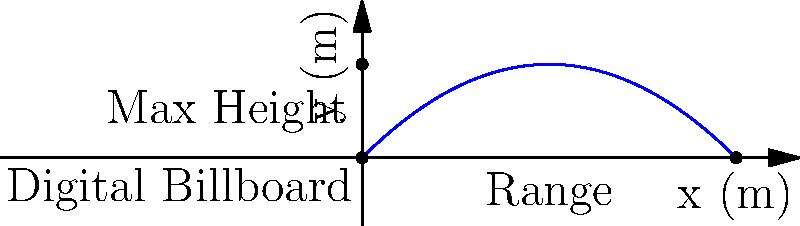A digital marketing campaign involves launching a small promotional device from the top of a digital billboard. The device is launched with an initial velocity of 20 m/s at an angle of 45° above the horizontal. Assuming air resistance is negligible, what is the maximum height reached by the device? How does this relate to the visibility of the campaign? To solve this problem, we'll follow these steps:

1) The maximum height is reached when the vertical velocity becomes zero. We can use the equation:

   $v_y = v_0 \sin \theta - gt$

   where $v_y$ is the vertical velocity, $v_0$ is the initial velocity, $\theta$ is the launch angle, $g$ is the acceleration due to gravity, and $t$ is time.

2) At the highest point, $v_y = 0$. So:

   $0 = v_0 \sin \theta - gt_{max}$

3) Solve for $t_{max}$:

   $t_{max} = \frac{v_0 \sin \theta}{g}$

4) Substitute the given values:

   $t_{max} = \frac{20 \sin 45°}{9.8} \approx 1.44$ seconds

5) Now, use the equation for the height:

   $y = v_0 \sin \theta \cdot t - \frac{1}{2}gt^2$

6) The maximum height occurs at $t = t_{max}/2$, so:

   $h_{max} = v_0 \sin \theta \cdot (\frac{t_{max}}{2}) - \frac{1}{2}g(\frac{t_{max}}{2})^2$

7) Simplify:

   $h_{max} = \frac{(v_0 \sin \theta)^2}{2g}$

8) Substitute the values:

   $h_{max} = \frac{(20 \sin 45°)^2}{2(9.8)} \approx 10.2$ meters

This height relates to the visibility of the campaign as it represents the maximum vertical distance the promotional device will travel. A higher trajectory increases the chances of the device being seen by a larger audience, potentially improving the reach of the digital marketing campaign.
Answer: 10.2 meters 